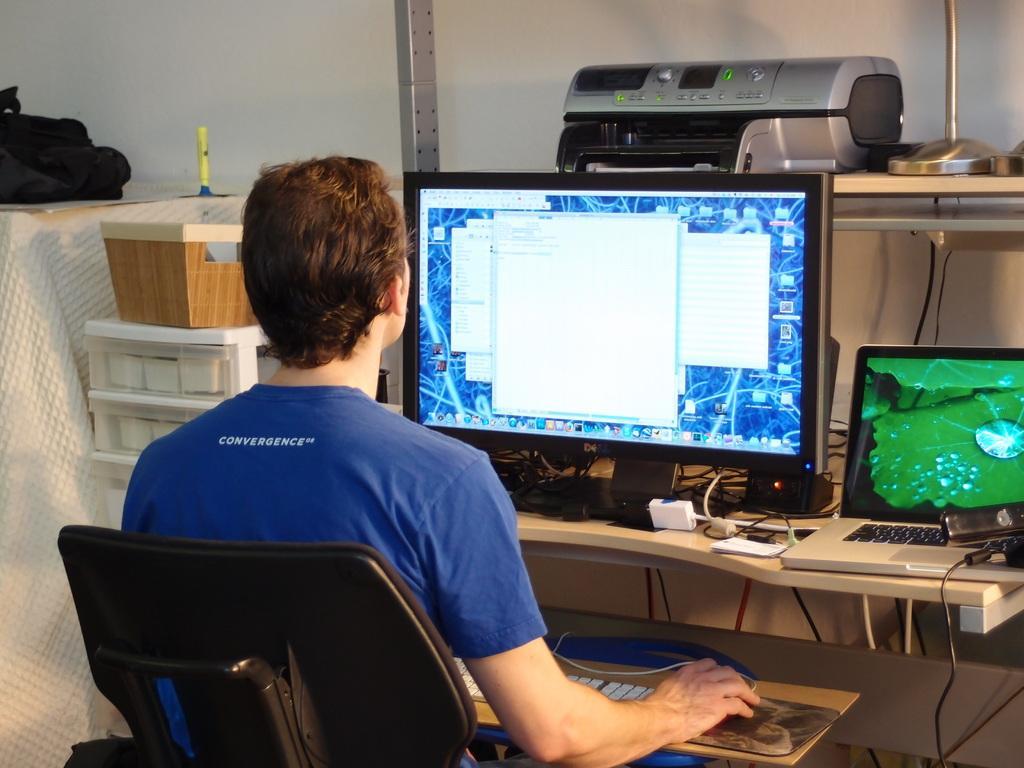Could you give a brief overview of what you see in this image? In the middle of the image a man is sitting on the chair and looking into a computer. Behind the computer there is a electronic device. Bottom right side of the image there is table, On the table there is a laptop. Top left side of the image there is a bag. 